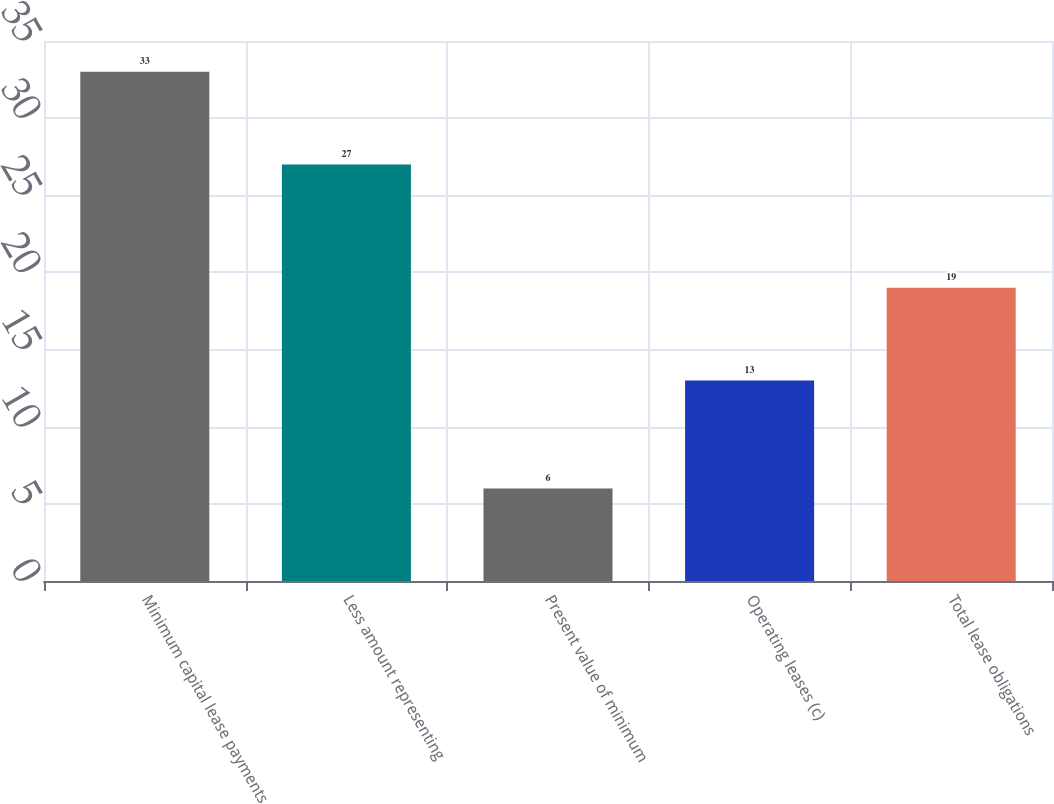Convert chart. <chart><loc_0><loc_0><loc_500><loc_500><bar_chart><fcel>Minimum capital lease payments<fcel>Less amount representing<fcel>Present value of minimum<fcel>Operating leases (c)<fcel>Total lease obligations<nl><fcel>33<fcel>27<fcel>6<fcel>13<fcel>19<nl></chart> 